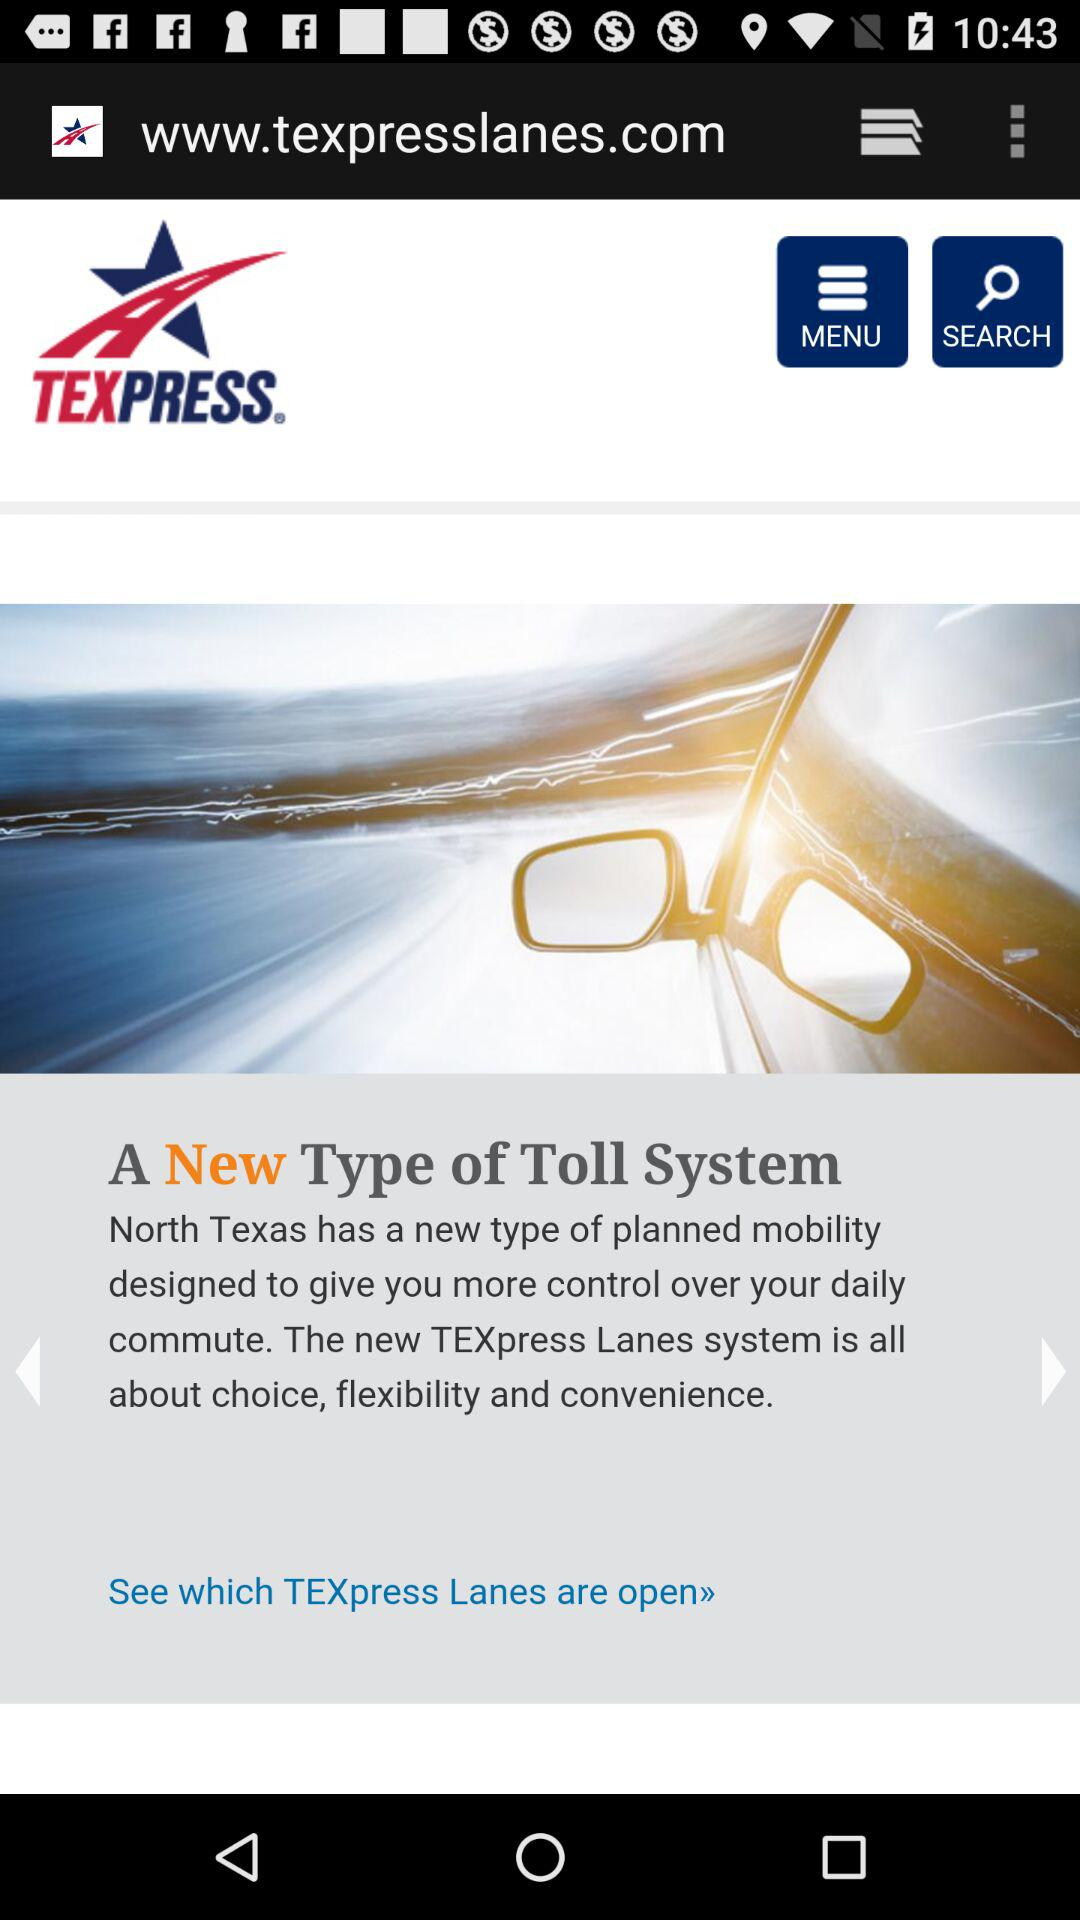What is the application name? The application name is "TEXPRESS". 